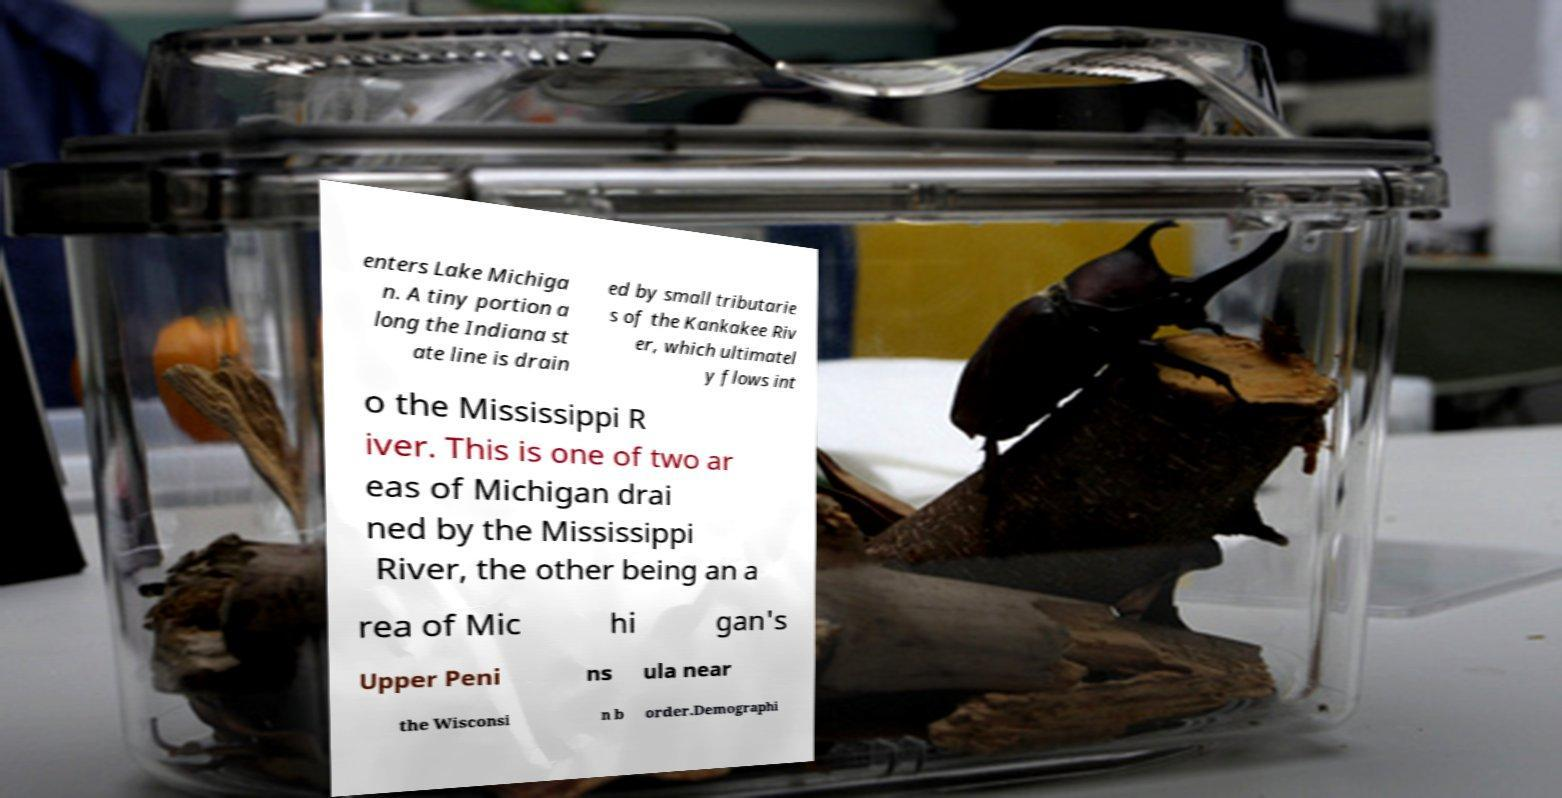Please read and relay the text visible in this image. What does it say? enters Lake Michiga n. A tiny portion a long the Indiana st ate line is drain ed by small tributarie s of the Kankakee Riv er, which ultimatel y flows int o the Mississippi R iver. This is one of two ar eas of Michigan drai ned by the Mississippi River, the other being an a rea of Mic hi gan's Upper Peni ns ula near the Wisconsi n b order.Demographi 